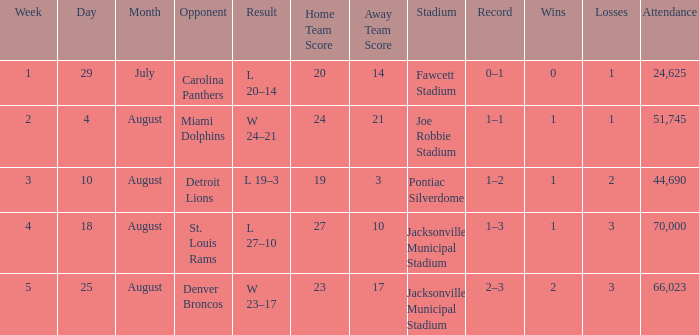WHEN has a Result of w 23–17? August 25. 